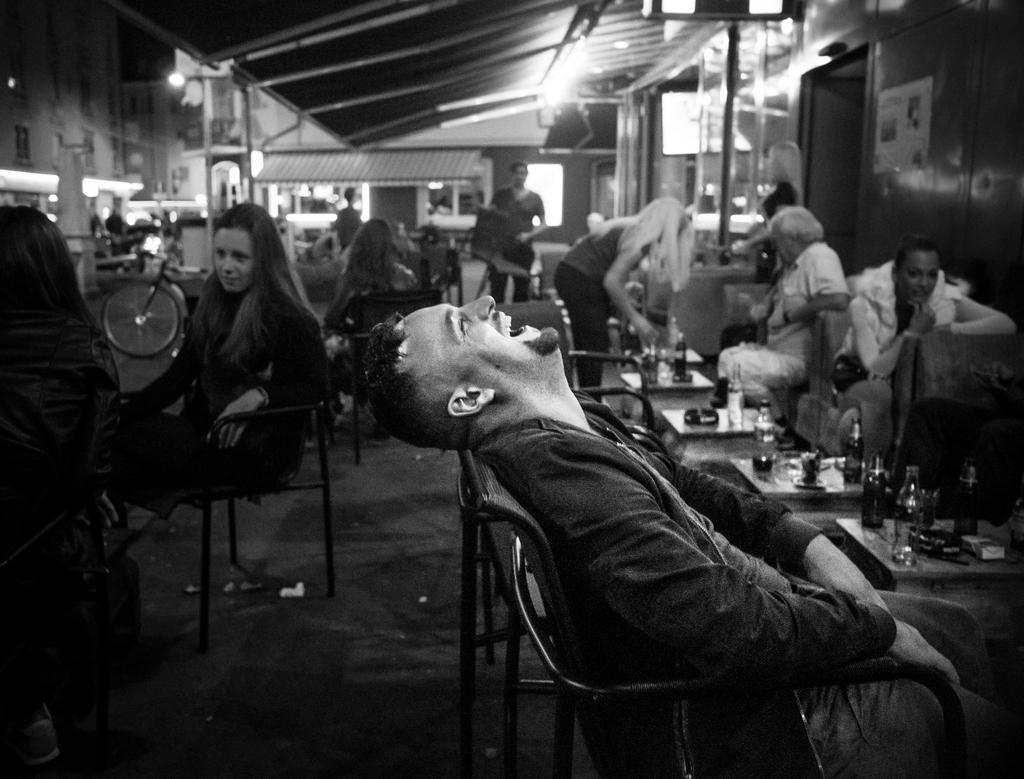In one or two sentences, can you explain what this image depicts? This is a black and white image and here we can see many people sitting on chairs and there are bottles on the table. In the background, there is shed and we can see a bicycle and some poles. 